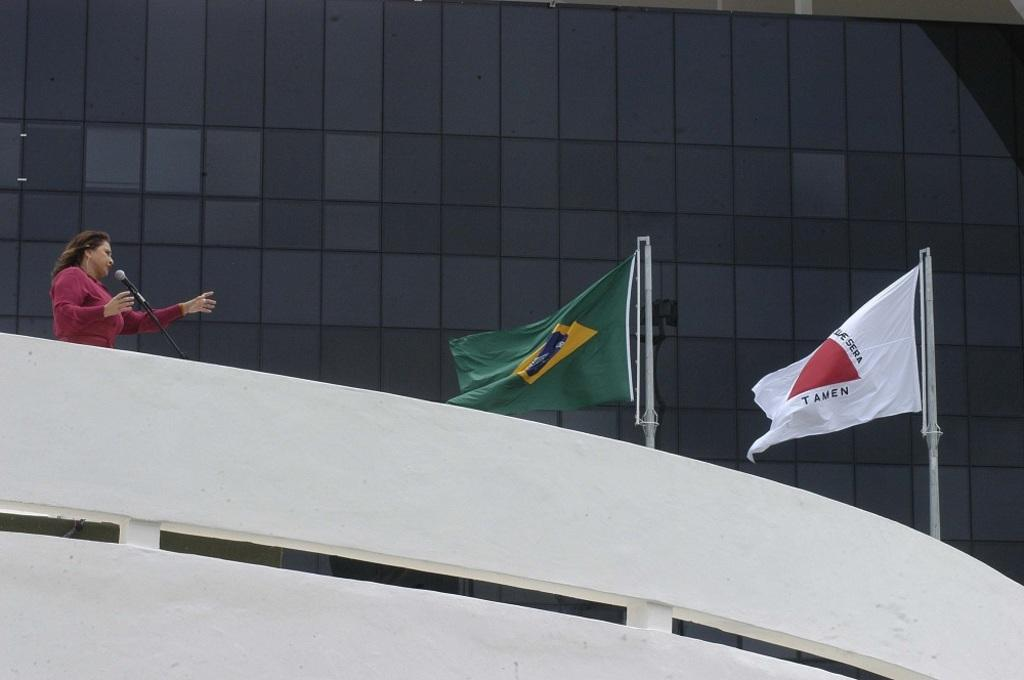What is the lady in the image doing? The lady is standing in the image. Where is the lady located in the image? The lady is on the left side of the image. What object is in front of the lady? There is a microphone in front of the lady. How many flags are visible in the image? There are two flags in the image. What can be seen in the background of the image? There is a building in the background of the image. Can you hear the alarm going off in the image? There is no alarm present in the image, so it cannot be heard. 